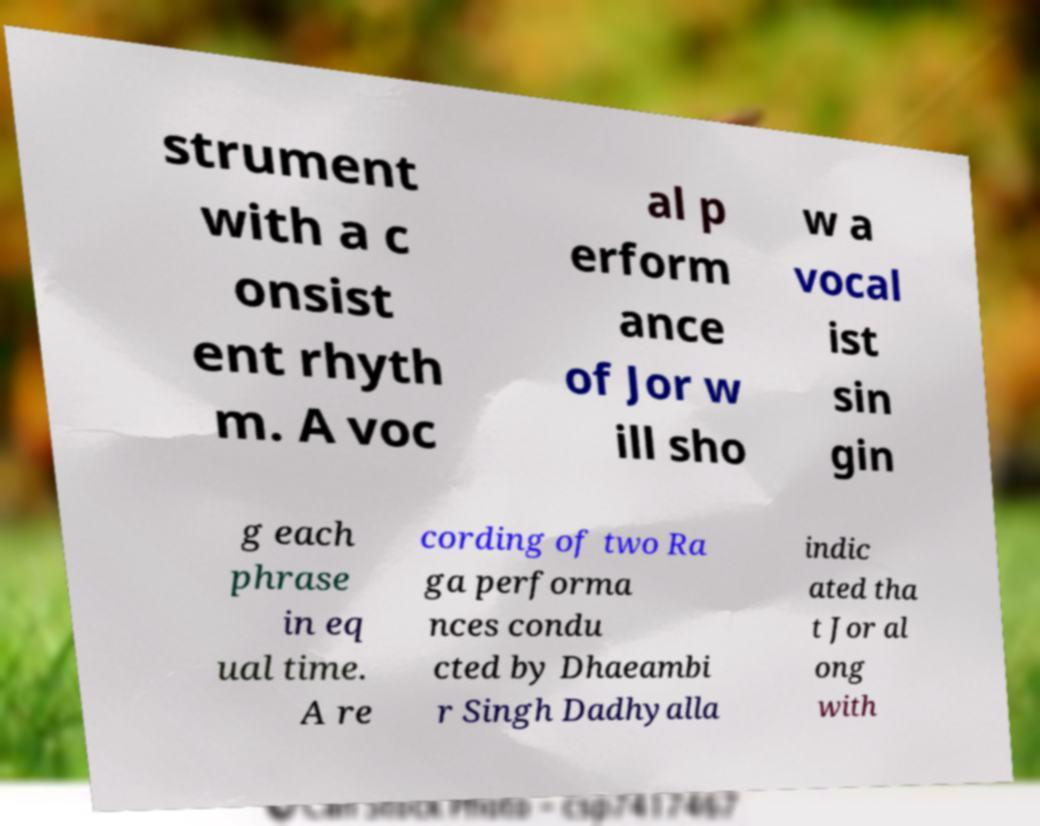Can you read and provide the text displayed in the image?This photo seems to have some interesting text. Can you extract and type it out for me? strument with a c onsist ent rhyth m. A voc al p erform ance of Jor w ill sho w a vocal ist sin gin g each phrase in eq ual time. A re cording of two Ra ga performa nces condu cted by Dhaeambi r Singh Dadhyalla indic ated tha t Jor al ong with 